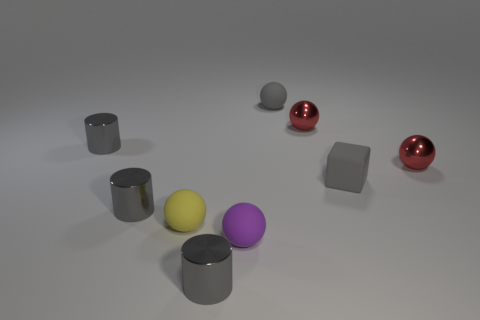Subtract 2 spheres. How many spheres are left? 3 Subtract all purple rubber balls. How many balls are left? 4 Subtract all yellow spheres. How many spheres are left? 4 Subtract all green spheres. Subtract all cyan cylinders. How many spheres are left? 5 Add 1 gray matte blocks. How many objects exist? 10 Subtract all cylinders. How many objects are left? 6 Subtract all purple matte spheres. Subtract all small purple rubber cylinders. How many objects are left? 8 Add 1 small red balls. How many small red balls are left? 3 Add 3 large yellow metallic things. How many large yellow metallic things exist? 3 Subtract 0 cyan blocks. How many objects are left? 9 